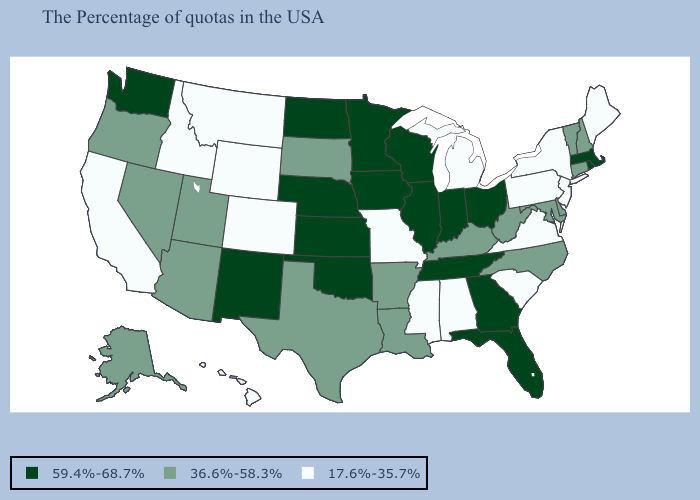What is the value of Louisiana?
Concise answer only. 36.6%-58.3%. Name the states that have a value in the range 36.6%-58.3%?
Be succinct. New Hampshire, Vermont, Connecticut, Delaware, Maryland, North Carolina, West Virginia, Kentucky, Louisiana, Arkansas, Texas, South Dakota, Utah, Arizona, Nevada, Oregon, Alaska. What is the value of Nebraska?
Concise answer only. 59.4%-68.7%. Name the states that have a value in the range 59.4%-68.7%?
Concise answer only. Massachusetts, Rhode Island, Ohio, Florida, Georgia, Indiana, Tennessee, Wisconsin, Illinois, Minnesota, Iowa, Kansas, Nebraska, Oklahoma, North Dakota, New Mexico, Washington. Name the states that have a value in the range 36.6%-58.3%?
Concise answer only. New Hampshire, Vermont, Connecticut, Delaware, Maryland, North Carolina, West Virginia, Kentucky, Louisiana, Arkansas, Texas, South Dakota, Utah, Arizona, Nevada, Oregon, Alaska. Which states have the lowest value in the MidWest?
Concise answer only. Michigan, Missouri. Does Oregon have the lowest value in the West?
Answer briefly. No. Name the states that have a value in the range 59.4%-68.7%?
Quick response, please. Massachusetts, Rhode Island, Ohio, Florida, Georgia, Indiana, Tennessee, Wisconsin, Illinois, Minnesota, Iowa, Kansas, Nebraska, Oklahoma, North Dakota, New Mexico, Washington. What is the highest value in states that border Missouri?
Concise answer only. 59.4%-68.7%. What is the value of New Hampshire?
Give a very brief answer. 36.6%-58.3%. Name the states that have a value in the range 36.6%-58.3%?
Write a very short answer. New Hampshire, Vermont, Connecticut, Delaware, Maryland, North Carolina, West Virginia, Kentucky, Louisiana, Arkansas, Texas, South Dakota, Utah, Arizona, Nevada, Oregon, Alaska. What is the value of Utah?
Write a very short answer. 36.6%-58.3%. Does New Jersey have the highest value in the USA?
Quick response, please. No. What is the value of Texas?
Answer briefly. 36.6%-58.3%. Name the states that have a value in the range 36.6%-58.3%?
Give a very brief answer. New Hampshire, Vermont, Connecticut, Delaware, Maryland, North Carolina, West Virginia, Kentucky, Louisiana, Arkansas, Texas, South Dakota, Utah, Arizona, Nevada, Oregon, Alaska. 